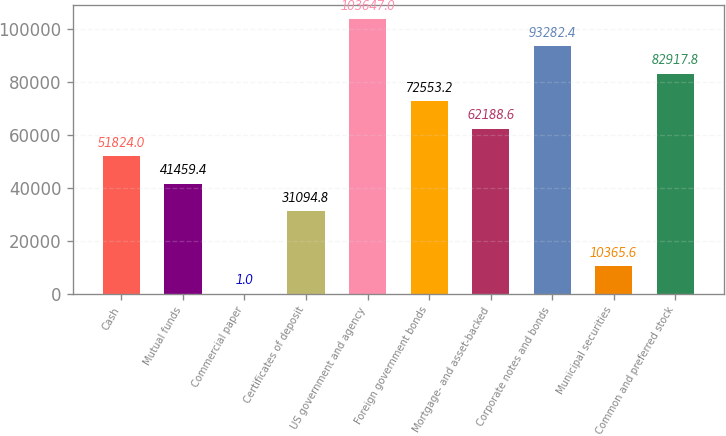Convert chart to OTSL. <chart><loc_0><loc_0><loc_500><loc_500><bar_chart><fcel>Cash<fcel>Mutual funds<fcel>Commercial paper<fcel>Certificates of deposit<fcel>US government and agency<fcel>Foreign government bonds<fcel>Mortgage- and asset-backed<fcel>Corporate notes and bonds<fcel>Municipal securities<fcel>Common and preferred stock<nl><fcel>51824<fcel>41459.4<fcel>1<fcel>31094.8<fcel>103647<fcel>72553.2<fcel>62188.6<fcel>93282.4<fcel>10365.6<fcel>82917.8<nl></chart> 